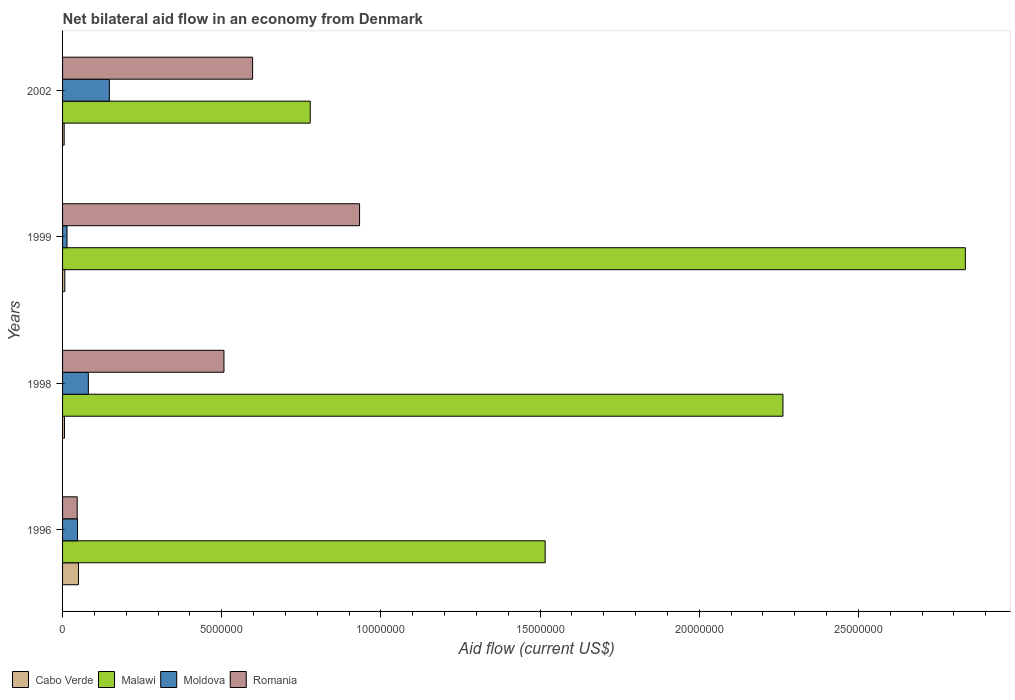How many groups of bars are there?
Keep it short and to the point. 4. How many bars are there on the 1st tick from the top?
Your response must be concise. 4. What is the net bilateral aid flow in Cabo Verde in 1998?
Offer a terse response. 6.00e+04. In which year was the net bilateral aid flow in Cabo Verde minimum?
Provide a short and direct response. 2002. What is the total net bilateral aid flow in Cabo Verde in the graph?
Make the answer very short. 6.80e+05. What is the difference between the net bilateral aid flow in Romania in 1996 and that in 2002?
Your answer should be compact. -5.51e+06. What is the difference between the net bilateral aid flow in Cabo Verde in 1999 and the net bilateral aid flow in Malawi in 2002?
Ensure brevity in your answer.  -7.71e+06. What is the average net bilateral aid flow in Romania per year?
Make the answer very short. 5.21e+06. In the year 1998, what is the difference between the net bilateral aid flow in Moldova and net bilateral aid flow in Malawi?
Offer a terse response. -2.18e+07. What is the difference between the highest and the second highest net bilateral aid flow in Malawi?
Your answer should be compact. 5.73e+06. Is the sum of the net bilateral aid flow in Cabo Verde in 1998 and 2002 greater than the maximum net bilateral aid flow in Malawi across all years?
Your answer should be very brief. No. What does the 1st bar from the top in 1998 represents?
Offer a terse response. Romania. What does the 3rd bar from the bottom in 1998 represents?
Your answer should be very brief. Moldova. Is it the case that in every year, the sum of the net bilateral aid flow in Cabo Verde and net bilateral aid flow in Moldova is greater than the net bilateral aid flow in Malawi?
Offer a terse response. No. What is the difference between two consecutive major ticks on the X-axis?
Your response must be concise. 5.00e+06. Are the values on the major ticks of X-axis written in scientific E-notation?
Ensure brevity in your answer.  No. Does the graph contain any zero values?
Your answer should be very brief. No. How many legend labels are there?
Make the answer very short. 4. What is the title of the graph?
Provide a succinct answer. Net bilateral aid flow in an economy from Denmark. What is the label or title of the X-axis?
Ensure brevity in your answer.  Aid flow (current US$). What is the label or title of the Y-axis?
Your answer should be very brief. Years. What is the Aid flow (current US$) of Cabo Verde in 1996?
Make the answer very short. 5.00e+05. What is the Aid flow (current US$) in Malawi in 1996?
Keep it short and to the point. 1.52e+07. What is the Aid flow (current US$) of Malawi in 1998?
Your response must be concise. 2.26e+07. What is the Aid flow (current US$) of Moldova in 1998?
Provide a succinct answer. 8.10e+05. What is the Aid flow (current US$) in Romania in 1998?
Offer a very short reply. 5.07e+06. What is the Aid flow (current US$) in Malawi in 1999?
Provide a succinct answer. 2.84e+07. What is the Aid flow (current US$) in Romania in 1999?
Give a very brief answer. 9.33e+06. What is the Aid flow (current US$) of Malawi in 2002?
Make the answer very short. 7.78e+06. What is the Aid flow (current US$) in Moldova in 2002?
Offer a terse response. 1.47e+06. What is the Aid flow (current US$) of Romania in 2002?
Offer a very short reply. 5.97e+06. Across all years, what is the maximum Aid flow (current US$) in Malawi?
Make the answer very short. 2.84e+07. Across all years, what is the maximum Aid flow (current US$) in Moldova?
Your answer should be compact. 1.47e+06. Across all years, what is the maximum Aid flow (current US$) in Romania?
Provide a succinct answer. 9.33e+06. Across all years, what is the minimum Aid flow (current US$) of Malawi?
Keep it short and to the point. 7.78e+06. Across all years, what is the minimum Aid flow (current US$) of Moldova?
Keep it short and to the point. 1.40e+05. Across all years, what is the minimum Aid flow (current US$) in Romania?
Keep it short and to the point. 4.60e+05. What is the total Aid flow (current US$) of Cabo Verde in the graph?
Offer a terse response. 6.80e+05. What is the total Aid flow (current US$) in Malawi in the graph?
Provide a short and direct response. 7.39e+07. What is the total Aid flow (current US$) in Moldova in the graph?
Provide a short and direct response. 2.89e+06. What is the total Aid flow (current US$) of Romania in the graph?
Keep it short and to the point. 2.08e+07. What is the difference between the Aid flow (current US$) of Malawi in 1996 and that in 1998?
Offer a terse response. -7.47e+06. What is the difference between the Aid flow (current US$) of Moldova in 1996 and that in 1998?
Make the answer very short. -3.40e+05. What is the difference between the Aid flow (current US$) in Romania in 1996 and that in 1998?
Provide a succinct answer. -4.61e+06. What is the difference between the Aid flow (current US$) of Malawi in 1996 and that in 1999?
Give a very brief answer. -1.32e+07. What is the difference between the Aid flow (current US$) of Romania in 1996 and that in 1999?
Your answer should be compact. -8.87e+06. What is the difference between the Aid flow (current US$) in Cabo Verde in 1996 and that in 2002?
Offer a very short reply. 4.50e+05. What is the difference between the Aid flow (current US$) in Malawi in 1996 and that in 2002?
Ensure brevity in your answer.  7.38e+06. What is the difference between the Aid flow (current US$) in Moldova in 1996 and that in 2002?
Provide a short and direct response. -1.00e+06. What is the difference between the Aid flow (current US$) of Romania in 1996 and that in 2002?
Make the answer very short. -5.51e+06. What is the difference between the Aid flow (current US$) of Malawi in 1998 and that in 1999?
Make the answer very short. -5.73e+06. What is the difference between the Aid flow (current US$) in Moldova in 1998 and that in 1999?
Your answer should be very brief. 6.70e+05. What is the difference between the Aid flow (current US$) in Romania in 1998 and that in 1999?
Your answer should be very brief. -4.26e+06. What is the difference between the Aid flow (current US$) of Cabo Verde in 1998 and that in 2002?
Offer a very short reply. 10000. What is the difference between the Aid flow (current US$) of Malawi in 1998 and that in 2002?
Make the answer very short. 1.48e+07. What is the difference between the Aid flow (current US$) in Moldova in 1998 and that in 2002?
Give a very brief answer. -6.60e+05. What is the difference between the Aid flow (current US$) of Romania in 1998 and that in 2002?
Make the answer very short. -9.00e+05. What is the difference between the Aid flow (current US$) in Cabo Verde in 1999 and that in 2002?
Your answer should be very brief. 2.00e+04. What is the difference between the Aid flow (current US$) in Malawi in 1999 and that in 2002?
Give a very brief answer. 2.06e+07. What is the difference between the Aid flow (current US$) of Moldova in 1999 and that in 2002?
Keep it short and to the point. -1.33e+06. What is the difference between the Aid flow (current US$) of Romania in 1999 and that in 2002?
Provide a succinct answer. 3.36e+06. What is the difference between the Aid flow (current US$) of Cabo Verde in 1996 and the Aid flow (current US$) of Malawi in 1998?
Provide a succinct answer. -2.21e+07. What is the difference between the Aid flow (current US$) of Cabo Verde in 1996 and the Aid flow (current US$) of Moldova in 1998?
Your response must be concise. -3.10e+05. What is the difference between the Aid flow (current US$) of Cabo Verde in 1996 and the Aid flow (current US$) of Romania in 1998?
Give a very brief answer. -4.57e+06. What is the difference between the Aid flow (current US$) in Malawi in 1996 and the Aid flow (current US$) in Moldova in 1998?
Offer a very short reply. 1.44e+07. What is the difference between the Aid flow (current US$) of Malawi in 1996 and the Aid flow (current US$) of Romania in 1998?
Ensure brevity in your answer.  1.01e+07. What is the difference between the Aid flow (current US$) in Moldova in 1996 and the Aid flow (current US$) in Romania in 1998?
Your answer should be very brief. -4.60e+06. What is the difference between the Aid flow (current US$) of Cabo Verde in 1996 and the Aid flow (current US$) of Malawi in 1999?
Keep it short and to the point. -2.79e+07. What is the difference between the Aid flow (current US$) in Cabo Verde in 1996 and the Aid flow (current US$) in Moldova in 1999?
Provide a succinct answer. 3.60e+05. What is the difference between the Aid flow (current US$) in Cabo Verde in 1996 and the Aid flow (current US$) in Romania in 1999?
Your answer should be very brief. -8.83e+06. What is the difference between the Aid flow (current US$) of Malawi in 1996 and the Aid flow (current US$) of Moldova in 1999?
Offer a terse response. 1.50e+07. What is the difference between the Aid flow (current US$) in Malawi in 1996 and the Aid flow (current US$) in Romania in 1999?
Provide a short and direct response. 5.83e+06. What is the difference between the Aid flow (current US$) of Moldova in 1996 and the Aid flow (current US$) of Romania in 1999?
Provide a succinct answer. -8.86e+06. What is the difference between the Aid flow (current US$) in Cabo Verde in 1996 and the Aid flow (current US$) in Malawi in 2002?
Offer a very short reply. -7.28e+06. What is the difference between the Aid flow (current US$) of Cabo Verde in 1996 and the Aid flow (current US$) of Moldova in 2002?
Offer a terse response. -9.70e+05. What is the difference between the Aid flow (current US$) in Cabo Verde in 1996 and the Aid flow (current US$) in Romania in 2002?
Make the answer very short. -5.47e+06. What is the difference between the Aid flow (current US$) of Malawi in 1996 and the Aid flow (current US$) of Moldova in 2002?
Offer a terse response. 1.37e+07. What is the difference between the Aid flow (current US$) of Malawi in 1996 and the Aid flow (current US$) of Romania in 2002?
Ensure brevity in your answer.  9.19e+06. What is the difference between the Aid flow (current US$) of Moldova in 1996 and the Aid flow (current US$) of Romania in 2002?
Offer a very short reply. -5.50e+06. What is the difference between the Aid flow (current US$) in Cabo Verde in 1998 and the Aid flow (current US$) in Malawi in 1999?
Your answer should be compact. -2.83e+07. What is the difference between the Aid flow (current US$) in Cabo Verde in 1998 and the Aid flow (current US$) in Moldova in 1999?
Offer a very short reply. -8.00e+04. What is the difference between the Aid flow (current US$) of Cabo Verde in 1998 and the Aid flow (current US$) of Romania in 1999?
Your response must be concise. -9.27e+06. What is the difference between the Aid flow (current US$) in Malawi in 1998 and the Aid flow (current US$) in Moldova in 1999?
Your answer should be very brief. 2.25e+07. What is the difference between the Aid flow (current US$) in Malawi in 1998 and the Aid flow (current US$) in Romania in 1999?
Provide a short and direct response. 1.33e+07. What is the difference between the Aid flow (current US$) in Moldova in 1998 and the Aid flow (current US$) in Romania in 1999?
Provide a succinct answer. -8.52e+06. What is the difference between the Aid flow (current US$) of Cabo Verde in 1998 and the Aid flow (current US$) of Malawi in 2002?
Make the answer very short. -7.72e+06. What is the difference between the Aid flow (current US$) of Cabo Verde in 1998 and the Aid flow (current US$) of Moldova in 2002?
Make the answer very short. -1.41e+06. What is the difference between the Aid flow (current US$) in Cabo Verde in 1998 and the Aid flow (current US$) in Romania in 2002?
Ensure brevity in your answer.  -5.91e+06. What is the difference between the Aid flow (current US$) of Malawi in 1998 and the Aid flow (current US$) of Moldova in 2002?
Provide a succinct answer. 2.12e+07. What is the difference between the Aid flow (current US$) of Malawi in 1998 and the Aid flow (current US$) of Romania in 2002?
Keep it short and to the point. 1.67e+07. What is the difference between the Aid flow (current US$) of Moldova in 1998 and the Aid flow (current US$) of Romania in 2002?
Offer a very short reply. -5.16e+06. What is the difference between the Aid flow (current US$) in Cabo Verde in 1999 and the Aid flow (current US$) in Malawi in 2002?
Provide a short and direct response. -7.71e+06. What is the difference between the Aid flow (current US$) of Cabo Verde in 1999 and the Aid flow (current US$) of Moldova in 2002?
Keep it short and to the point. -1.40e+06. What is the difference between the Aid flow (current US$) of Cabo Verde in 1999 and the Aid flow (current US$) of Romania in 2002?
Offer a very short reply. -5.90e+06. What is the difference between the Aid flow (current US$) of Malawi in 1999 and the Aid flow (current US$) of Moldova in 2002?
Ensure brevity in your answer.  2.69e+07. What is the difference between the Aid flow (current US$) in Malawi in 1999 and the Aid flow (current US$) in Romania in 2002?
Your answer should be very brief. 2.24e+07. What is the difference between the Aid flow (current US$) in Moldova in 1999 and the Aid flow (current US$) in Romania in 2002?
Provide a short and direct response. -5.83e+06. What is the average Aid flow (current US$) of Cabo Verde per year?
Give a very brief answer. 1.70e+05. What is the average Aid flow (current US$) of Malawi per year?
Provide a short and direct response. 1.85e+07. What is the average Aid flow (current US$) of Moldova per year?
Provide a succinct answer. 7.22e+05. What is the average Aid flow (current US$) in Romania per year?
Ensure brevity in your answer.  5.21e+06. In the year 1996, what is the difference between the Aid flow (current US$) in Cabo Verde and Aid flow (current US$) in Malawi?
Provide a succinct answer. -1.47e+07. In the year 1996, what is the difference between the Aid flow (current US$) in Cabo Verde and Aid flow (current US$) in Romania?
Provide a short and direct response. 4.00e+04. In the year 1996, what is the difference between the Aid flow (current US$) of Malawi and Aid flow (current US$) of Moldova?
Ensure brevity in your answer.  1.47e+07. In the year 1996, what is the difference between the Aid flow (current US$) of Malawi and Aid flow (current US$) of Romania?
Keep it short and to the point. 1.47e+07. In the year 1996, what is the difference between the Aid flow (current US$) of Moldova and Aid flow (current US$) of Romania?
Make the answer very short. 10000. In the year 1998, what is the difference between the Aid flow (current US$) in Cabo Verde and Aid flow (current US$) in Malawi?
Offer a very short reply. -2.26e+07. In the year 1998, what is the difference between the Aid flow (current US$) in Cabo Verde and Aid flow (current US$) in Moldova?
Give a very brief answer. -7.50e+05. In the year 1998, what is the difference between the Aid flow (current US$) of Cabo Verde and Aid flow (current US$) of Romania?
Your response must be concise. -5.01e+06. In the year 1998, what is the difference between the Aid flow (current US$) in Malawi and Aid flow (current US$) in Moldova?
Your answer should be very brief. 2.18e+07. In the year 1998, what is the difference between the Aid flow (current US$) in Malawi and Aid flow (current US$) in Romania?
Provide a short and direct response. 1.76e+07. In the year 1998, what is the difference between the Aid flow (current US$) in Moldova and Aid flow (current US$) in Romania?
Offer a very short reply. -4.26e+06. In the year 1999, what is the difference between the Aid flow (current US$) in Cabo Verde and Aid flow (current US$) in Malawi?
Give a very brief answer. -2.83e+07. In the year 1999, what is the difference between the Aid flow (current US$) in Cabo Verde and Aid flow (current US$) in Moldova?
Make the answer very short. -7.00e+04. In the year 1999, what is the difference between the Aid flow (current US$) of Cabo Verde and Aid flow (current US$) of Romania?
Your response must be concise. -9.26e+06. In the year 1999, what is the difference between the Aid flow (current US$) in Malawi and Aid flow (current US$) in Moldova?
Your answer should be compact. 2.82e+07. In the year 1999, what is the difference between the Aid flow (current US$) in Malawi and Aid flow (current US$) in Romania?
Keep it short and to the point. 1.90e+07. In the year 1999, what is the difference between the Aid flow (current US$) of Moldova and Aid flow (current US$) of Romania?
Keep it short and to the point. -9.19e+06. In the year 2002, what is the difference between the Aid flow (current US$) of Cabo Verde and Aid flow (current US$) of Malawi?
Your answer should be compact. -7.73e+06. In the year 2002, what is the difference between the Aid flow (current US$) in Cabo Verde and Aid flow (current US$) in Moldova?
Provide a succinct answer. -1.42e+06. In the year 2002, what is the difference between the Aid flow (current US$) of Cabo Verde and Aid flow (current US$) of Romania?
Keep it short and to the point. -5.92e+06. In the year 2002, what is the difference between the Aid flow (current US$) of Malawi and Aid flow (current US$) of Moldova?
Offer a terse response. 6.31e+06. In the year 2002, what is the difference between the Aid flow (current US$) in Malawi and Aid flow (current US$) in Romania?
Your answer should be very brief. 1.81e+06. In the year 2002, what is the difference between the Aid flow (current US$) in Moldova and Aid flow (current US$) in Romania?
Give a very brief answer. -4.50e+06. What is the ratio of the Aid flow (current US$) of Cabo Verde in 1996 to that in 1998?
Offer a very short reply. 8.33. What is the ratio of the Aid flow (current US$) of Malawi in 1996 to that in 1998?
Provide a short and direct response. 0.67. What is the ratio of the Aid flow (current US$) of Moldova in 1996 to that in 1998?
Your answer should be very brief. 0.58. What is the ratio of the Aid flow (current US$) in Romania in 1996 to that in 1998?
Offer a very short reply. 0.09. What is the ratio of the Aid flow (current US$) in Cabo Verde in 1996 to that in 1999?
Offer a terse response. 7.14. What is the ratio of the Aid flow (current US$) of Malawi in 1996 to that in 1999?
Your answer should be very brief. 0.53. What is the ratio of the Aid flow (current US$) in Moldova in 1996 to that in 1999?
Your answer should be very brief. 3.36. What is the ratio of the Aid flow (current US$) of Romania in 1996 to that in 1999?
Your answer should be very brief. 0.05. What is the ratio of the Aid flow (current US$) in Malawi in 1996 to that in 2002?
Provide a short and direct response. 1.95. What is the ratio of the Aid flow (current US$) of Moldova in 1996 to that in 2002?
Keep it short and to the point. 0.32. What is the ratio of the Aid flow (current US$) in Romania in 1996 to that in 2002?
Your answer should be compact. 0.08. What is the ratio of the Aid flow (current US$) of Malawi in 1998 to that in 1999?
Keep it short and to the point. 0.8. What is the ratio of the Aid flow (current US$) of Moldova in 1998 to that in 1999?
Keep it short and to the point. 5.79. What is the ratio of the Aid flow (current US$) of Romania in 1998 to that in 1999?
Provide a short and direct response. 0.54. What is the ratio of the Aid flow (current US$) in Malawi in 1998 to that in 2002?
Give a very brief answer. 2.91. What is the ratio of the Aid flow (current US$) in Moldova in 1998 to that in 2002?
Offer a very short reply. 0.55. What is the ratio of the Aid flow (current US$) of Romania in 1998 to that in 2002?
Provide a succinct answer. 0.85. What is the ratio of the Aid flow (current US$) of Malawi in 1999 to that in 2002?
Make the answer very short. 3.65. What is the ratio of the Aid flow (current US$) in Moldova in 1999 to that in 2002?
Your response must be concise. 0.1. What is the ratio of the Aid flow (current US$) in Romania in 1999 to that in 2002?
Offer a very short reply. 1.56. What is the difference between the highest and the second highest Aid flow (current US$) in Malawi?
Your response must be concise. 5.73e+06. What is the difference between the highest and the second highest Aid flow (current US$) of Romania?
Make the answer very short. 3.36e+06. What is the difference between the highest and the lowest Aid flow (current US$) of Malawi?
Give a very brief answer. 2.06e+07. What is the difference between the highest and the lowest Aid flow (current US$) of Moldova?
Keep it short and to the point. 1.33e+06. What is the difference between the highest and the lowest Aid flow (current US$) in Romania?
Your answer should be compact. 8.87e+06. 